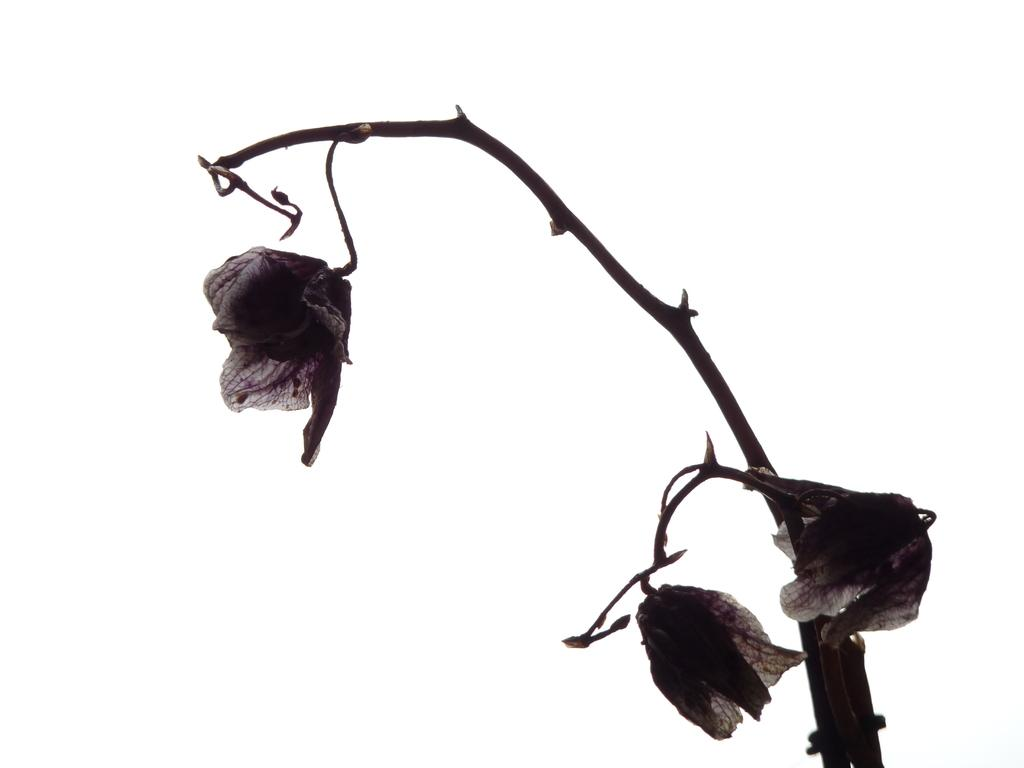What is the main object in the image? There is a stem in the image. What features can be observed on the stem? There are thorns on the stem, and dried flowers are attached to it. What is the color of the background in the image? The background of the image is white. How many children are crying in the image? There are no children or crying in the image; it features a stem with thorns and dried flowers against a white background. 